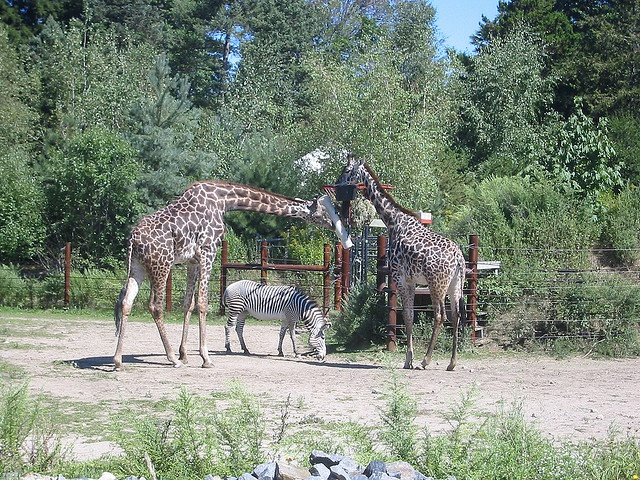Describe the objects in this image and their specific colors. I can see giraffe in darkgreen, gray, lightgray, and darkgray tones, giraffe in darkgreen, gray, darkgray, black, and lightgray tones, and zebra in darkgreen, lightgray, gray, darkgray, and black tones in this image. 